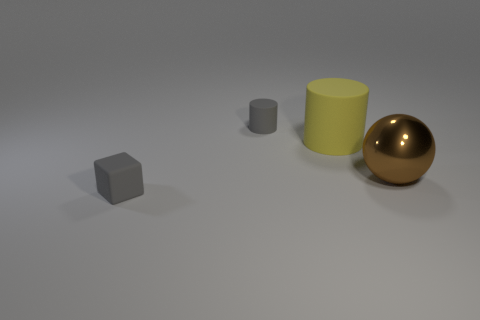Add 2 blue matte cylinders. How many objects exist? 6 Subtract all cubes. How many objects are left? 3 Subtract 1 gray cubes. How many objects are left? 3 Subtract all purple blocks. Subtract all yellow cylinders. How many blocks are left? 1 Subtract all cyan spheres. How many yellow cylinders are left? 1 Subtract all tiny gray blocks. Subtract all tiny cylinders. How many objects are left? 2 Add 2 small cubes. How many small cubes are left? 3 Add 2 big yellow objects. How many big yellow objects exist? 3 Subtract all gray cylinders. How many cylinders are left? 1 